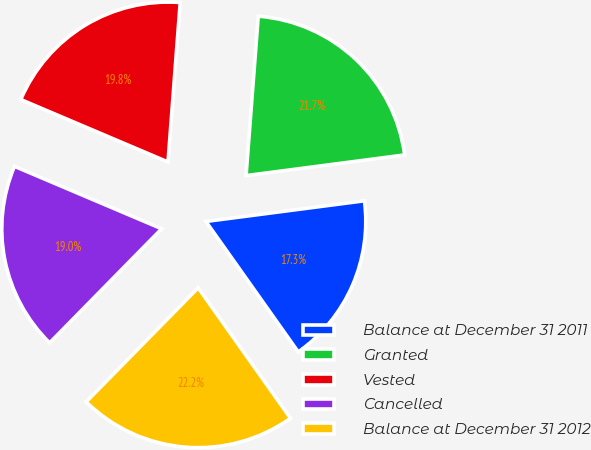Convert chart. <chart><loc_0><loc_0><loc_500><loc_500><pie_chart><fcel>Balance at December 31 2011<fcel>Granted<fcel>Vested<fcel>Cancelled<fcel>Balance at December 31 2012<nl><fcel>17.26%<fcel>21.72%<fcel>19.83%<fcel>19.03%<fcel>22.16%<nl></chart> 